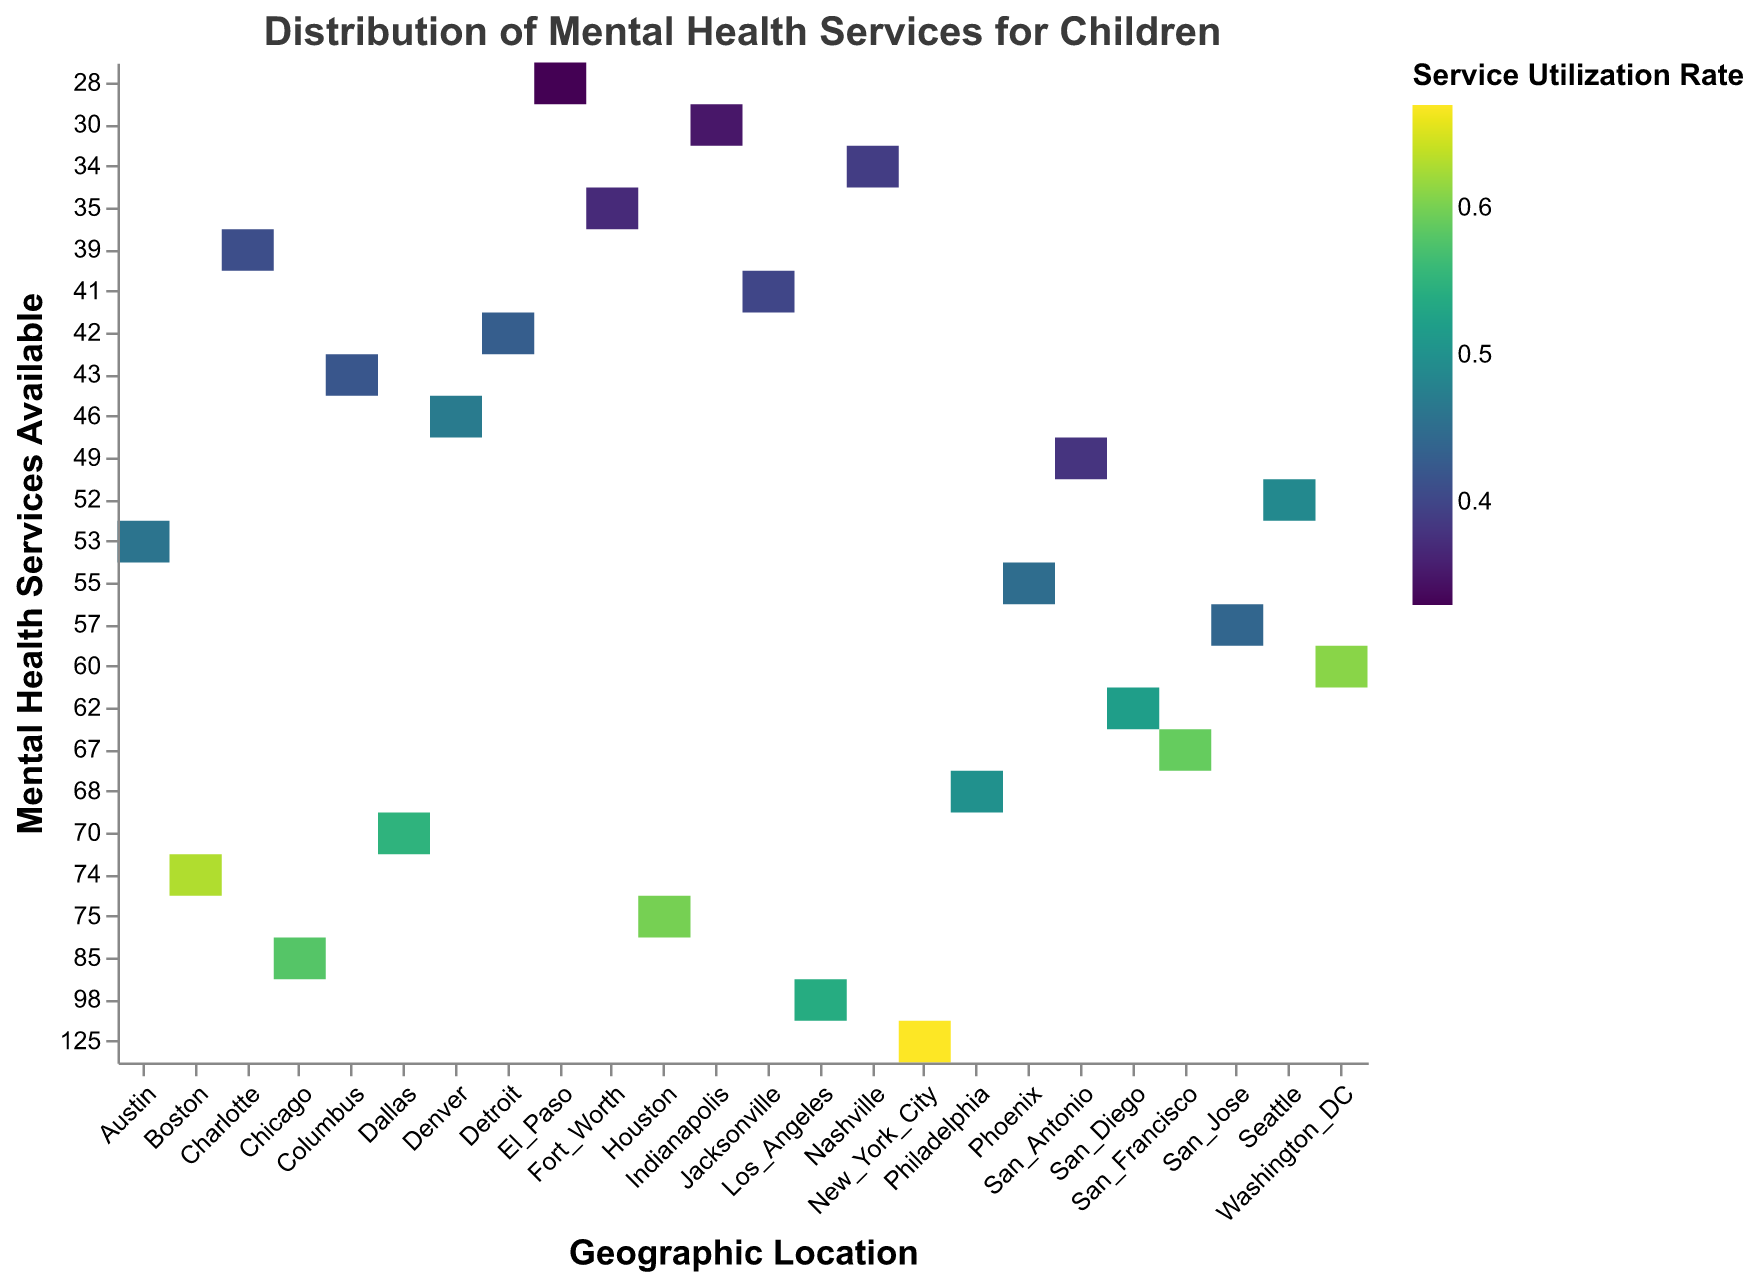What is the title of the Heatmap? The title of the heatmap is located at the top and it states the overall theme of the visualization, which is "Distribution of Mental Health Services for Children."
Answer: Distribution of Mental Health Services for Children Which geographic location has the highest number of available mental health services? By examining the y-axis which represents the number of mental health services available, the highest number is at "New York City" with 125 services.
Answer: New York City What color represents the highest service utilization rate? The highest service utilization rate would be the highest value in the color legend. By looking at the scale scheme which is Viridis, the brightest color represents the highest utilization rate.
Answer: Bright yellow Which geographic location has the lowest service utilization rate? By looking at the color mapping of all data points on the heatmap, "El Paso" has the lowest color hue indicating the lowest utilization rate of 0.33.
Answer: El Paso Compare the number of mental health services available in Chicago and San Diego. Looking at the y-axis for both "Chicago" and "San Diego," Chicago has 85 mental health services available whereas San Diego has 62.
Answer: Chicago has more services available than San Diego Which city has a similar service utilization rate and number of available services as Denver? Looking at Denver's values which are 46 services and a utilization rate of 0.47, we can see that Austin (53, 0.46) and Seattle (52, 0.49) have similar values.
Answer: Austin and Seattle What is the average service utilization rate of cities with more than 70 services? The cities with more than 70 services are New York City (125, 0.67), Los Angeles (98, 0.54), and Boston (74, 0.63). The average utilization rate is calculated as (0.67 + 0.54 + 0.63) / 3 = 0.61.
Answer: 0.61 Which city has the highest utilization rate with under 40 available services? By filtering down to cities with less than 40 services, "Nashville" with 34 services and a utilization rate of 0.39 has the highest utilization rate.
Answer: Nashville Determine if there is a correlation between the number of mental health services available and the service utilization rate. The heatmap indicates some correlation. For example, New York City has the highest services and one of the highest utilization rates while cities like El Paso with fewer services have the lowest utilization rate. However, more statistical analysis is needed for a definitive answer.
Answer: Positive correlation How does Washington DC's service utilization rate compare to Philadelphia's? By looking at the color density, Washington DC has a service utilization rate of 0.61 and Philadelphia has 0.50, making Washington DC's rate higher.
Answer: Washington DC has a higher rate 